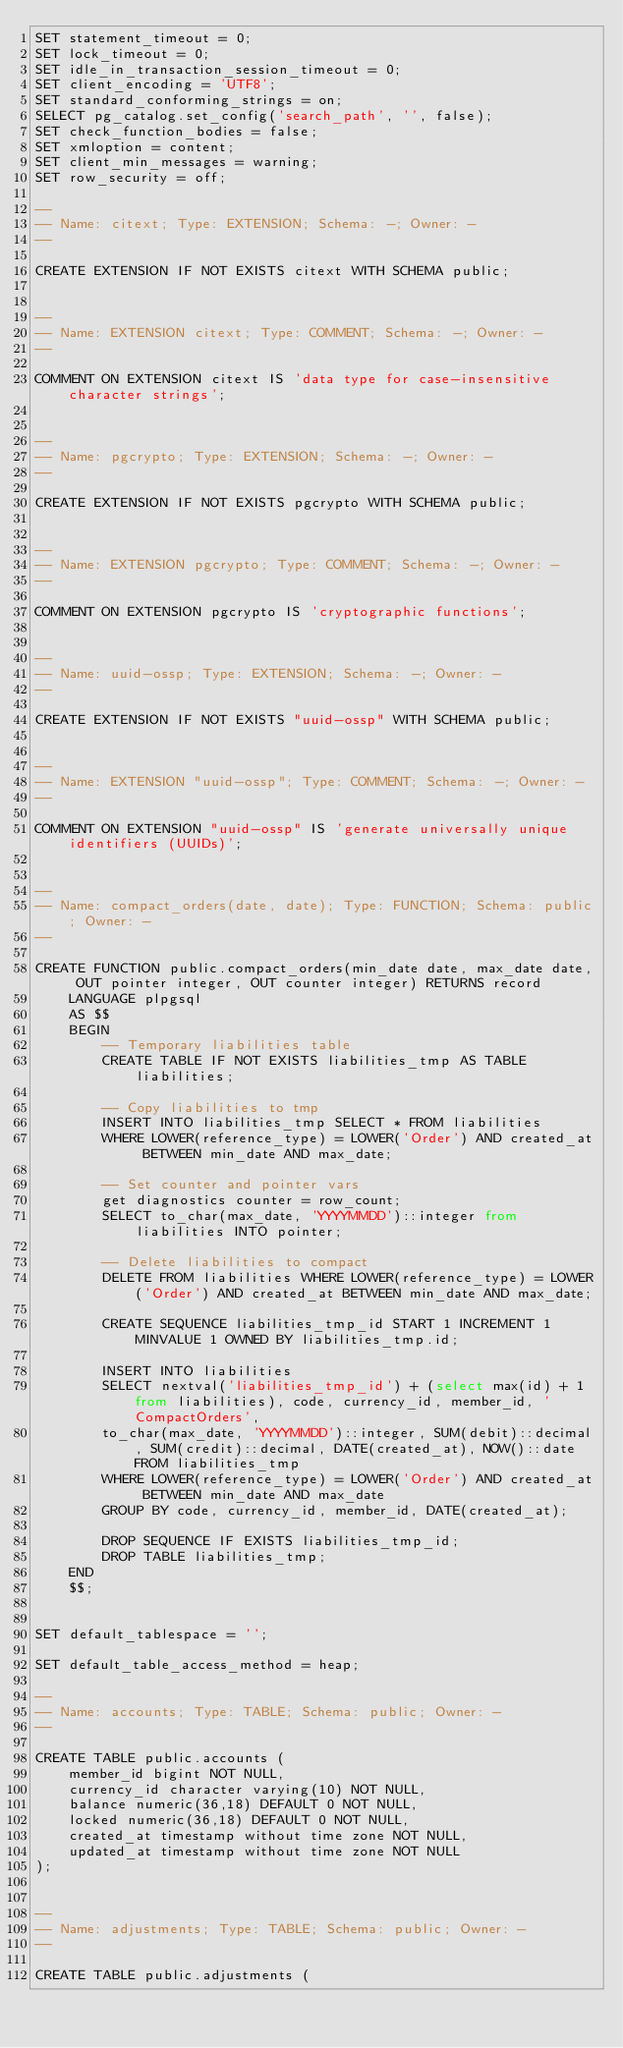<code> <loc_0><loc_0><loc_500><loc_500><_SQL_>SET statement_timeout = 0;
SET lock_timeout = 0;
SET idle_in_transaction_session_timeout = 0;
SET client_encoding = 'UTF8';
SET standard_conforming_strings = on;
SELECT pg_catalog.set_config('search_path', '', false);
SET check_function_bodies = false;
SET xmloption = content;
SET client_min_messages = warning;
SET row_security = off;

--
-- Name: citext; Type: EXTENSION; Schema: -; Owner: -
--

CREATE EXTENSION IF NOT EXISTS citext WITH SCHEMA public;


--
-- Name: EXTENSION citext; Type: COMMENT; Schema: -; Owner: -
--

COMMENT ON EXTENSION citext IS 'data type for case-insensitive character strings';


--
-- Name: pgcrypto; Type: EXTENSION; Schema: -; Owner: -
--

CREATE EXTENSION IF NOT EXISTS pgcrypto WITH SCHEMA public;


--
-- Name: EXTENSION pgcrypto; Type: COMMENT; Schema: -; Owner: -
--

COMMENT ON EXTENSION pgcrypto IS 'cryptographic functions';


--
-- Name: uuid-ossp; Type: EXTENSION; Schema: -; Owner: -
--

CREATE EXTENSION IF NOT EXISTS "uuid-ossp" WITH SCHEMA public;


--
-- Name: EXTENSION "uuid-ossp"; Type: COMMENT; Schema: -; Owner: -
--

COMMENT ON EXTENSION "uuid-ossp" IS 'generate universally unique identifiers (UUIDs)';


--
-- Name: compact_orders(date, date); Type: FUNCTION; Schema: public; Owner: -
--

CREATE FUNCTION public.compact_orders(min_date date, max_date date, OUT pointer integer, OUT counter integer) RETURNS record
    LANGUAGE plpgsql
    AS $$
    BEGIN
        -- Temporary liabilities table
        CREATE TABLE IF NOT EXISTS liabilities_tmp AS TABLE liabilities;

        -- Copy liabilities to tmp
        INSERT INTO liabilities_tmp SELECT * FROM liabilities
        WHERE LOWER(reference_type) = LOWER('Order') AND created_at BETWEEN min_date AND max_date;

        -- Set counter and pointer vars
        get diagnostics counter = row_count;
        SELECT to_char(max_date, 'YYYYMMDD')::integer from liabilities INTO pointer;

        -- Delete liabilities to compact
        DELETE FROM liabilities WHERE LOWER(reference_type) = LOWER('Order') AND created_at BETWEEN min_date AND max_date;

        CREATE SEQUENCE liabilities_tmp_id START 1 INCREMENT 1 MINVALUE 1 OWNED BY liabilities_tmp.id;

        INSERT INTO liabilities
        SELECT nextval('liabilities_tmp_id') + (select max(id) + 1 from liabilities), code, currency_id, member_id, 'CompactOrders',
        to_char(max_date, 'YYYYMMDD')::integer, SUM(debit)::decimal, SUM(credit)::decimal, DATE(created_at), NOW()::date FROM liabilities_tmp
        WHERE LOWER(reference_type) = LOWER('Order') AND created_at BETWEEN min_date AND max_date
        GROUP BY code, currency_id, member_id, DATE(created_at);

        DROP SEQUENCE IF EXISTS liabilities_tmp_id;
        DROP TABLE liabilities_tmp;
    END
    $$;


SET default_tablespace = '';

SET default_table_access_method = heap;

--
-- Name: accounts; Type: TABLE; Schema: public; Owner: -
--

CREATE TABLE public.accounts (
    member_id bigint NOT NULL,
    currency_id character varying(10) NOT NULL,
    balance numeric(36,18) DEFAULT 0 NOT NULL,
    locked numeric(36,18) DEFAULT 0 NOT NULL,
    created_at timestamp without time zone NOT NULL,
    updated_at timestamp without time zone NOT NULL
);


--
-- Name: adjustments; Type: TABLE; Schema: public; Owner: -
--

CREATE TABLE public.adjustments (</code> 